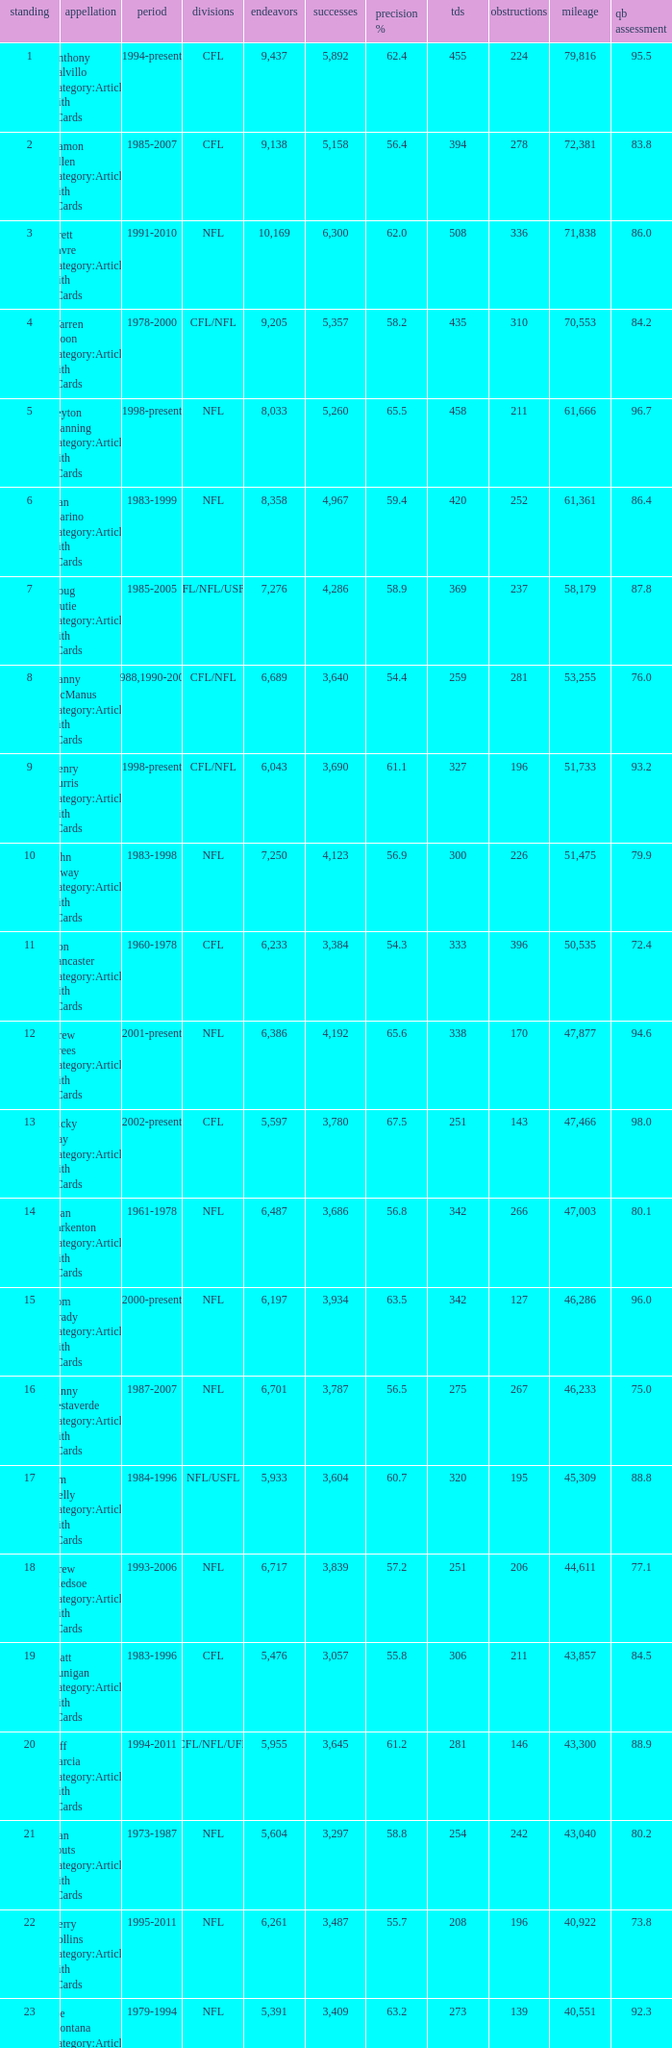What is the rank when there are more than 4,123 completion and the comp percentage is more than 65.6? None. 